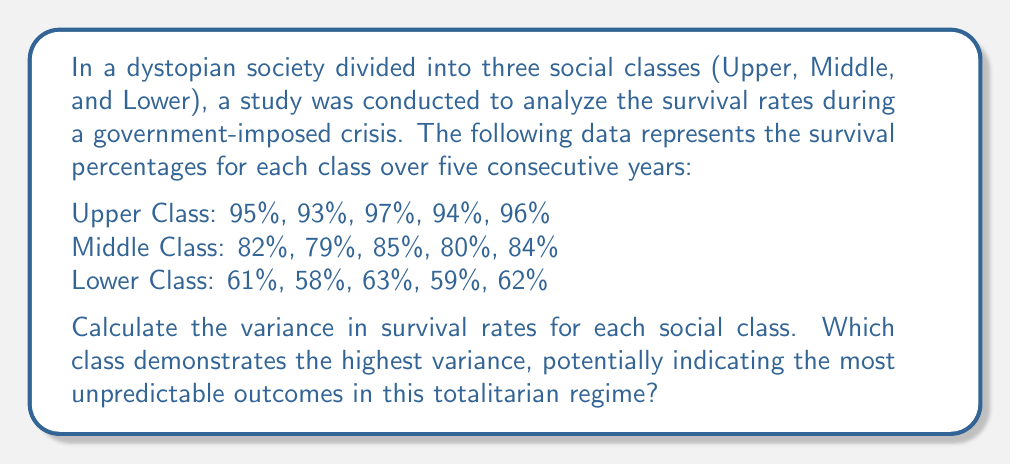Can you answer this question? To solve this problem, we need to calculate the variance for each social class using the formula:

$$ \text{Variance} = \frac{\sum_{i=1}^{n} (x_i - \bar{x})^2}{n} $$

Where $x_i$ represents each data point, $\bar{x}$ is the mean, and $n$ is the number of data points.

Step 1: Calculate the mean for each class.

Upper Class: $\bar{x}_U = \frac{95 + 93 + 97 + 94 + 96}{5} = 95$
Middle Class: $\bar{x}_M = \frac{82 + 79 + 85 + 80 + 84}{5} = 82$
Lower Class: $\bar{x}_L = \frac{61 + 58 + 63 + 59 + 62}{5} = 60.6$

Step 2: Calculate the squared differences from the mean for each class.

Upper Class:
$(95-95)^2 + (93-95)^2 + (97-95)^2 + (94-95)^2 + (96-95)^2 = 0 + 4 + 4 + 1 + 1 = 10$

Middle Class:
$(82-82)^2 + (79-82)^2 + (85-82)^2 + (80-82)^2 + (84-82)^2 = 0 + 9 + 9 + 4 + 4 = 26$

Lower Class:
$(61-60.6)^2 + (58-60.6)^2 + (63-60.6)^2 + (59-60.6)^2 + (62-60.6)^2 = 0.16 + 6.76 + 5.76 + 2.56 + 1.96 = 17.2$

Step 3: Calculate the variance for each class.

Upper Class: $\text{Variance}_U = \frac{10}{5} = 2$

Middle Class: $\text{Variance}_M = \frac{26}{5} = 5.2$

Lower Class: $\text{Variance}_L = \frac{17.2}{5} = 3.44$

Step 4: Compare the variances to determine which class has the highest variance.

The Middle Class has the highest variance at 5.2, followed by the Lower Class at 3.44, and the Upper Class at 2.
Answer: The Middle Class demonstrates the highest variance at 5.2, indicating the most unpredictable outcomes in this totalitarian regime. 